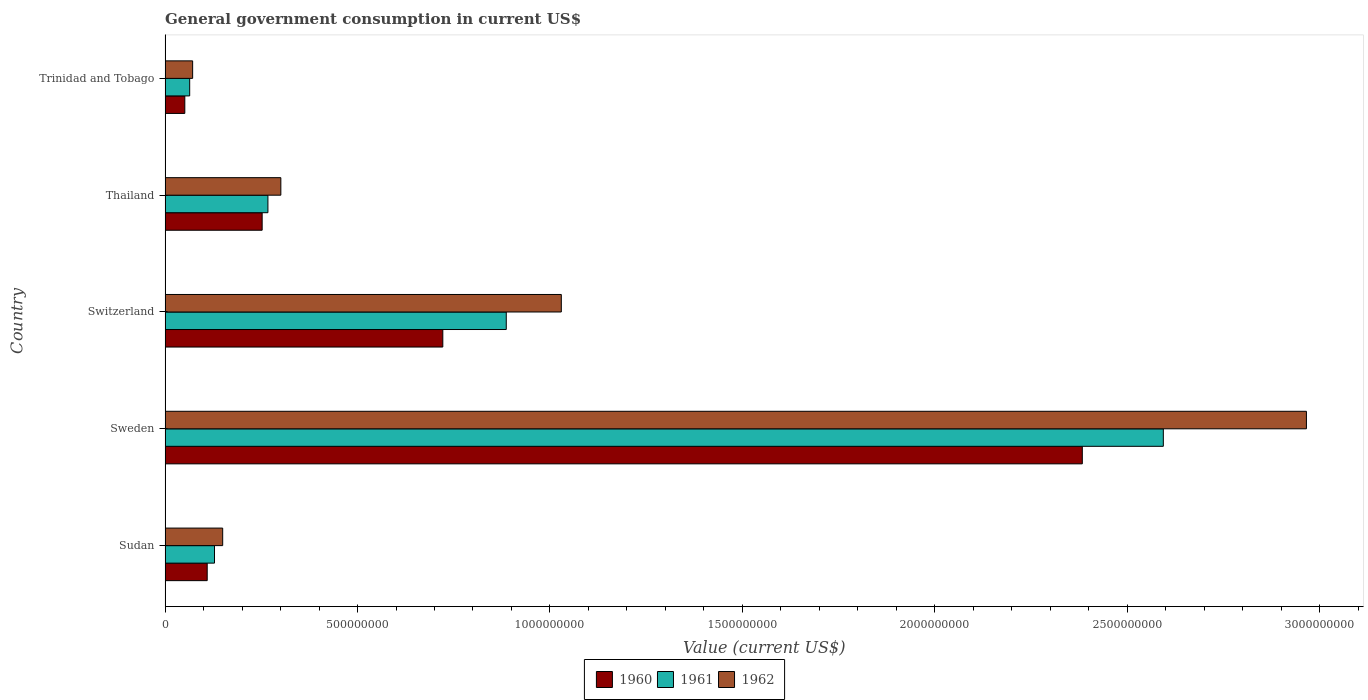How many different coloured bars are there?
Provide a short and direct response. 3. How many groups of bars are there?
Ensure brevity in your answer.  5. Are the number of bars per tick equal to the number of legend labels?
Offer a very short reply. Yes. How many bars are there on the 4th tick from the bottom?
Ensure brevity in your answer.  3. What is the label of the 2nd group of bars from the top?
Give a very brief answer. Thailand. In how many cases, is the number of bars for a given country not equal to the number of legend labels?
Provide a short and direct response. 0. What is the government conusmption in 1960 in Sudan?
Provide a succinct answer. 1.09e+08. Across all countries, what is the maximum government conusmption in 1962?
Provide a short and direct response. 2.97e+09. Across all countries, what is the minimum government conusmption in 1961?
Offer a very short reply. 6.39e+07. In which country was the government conusmption in 1960 maximum?
Give a very brief answer. Sweden. In which country was the government conusmption in 1962 minimum?
Offer a very short reply. Trinidad and Tobago. What is the total government conusmption in 1960 in the graph?
Your answer should be very brief. 3.52e+09. What is the difference between the government conusmption in 1960 in Thailand and that in Trinidad and Tobago?
Keep it short and to the point. 2.01e+08. What is the difference between the government conusmption in 1961 in Thailand and the government conusmption in 1962 in Sweden?
Give a very brief answer. -2.70e+09. What is the average government conusmption in 1961 per country?
Offer a very short reply. 7.88e+08. What is the difference between the government conusmption in 1962 and government conusmption in 1960 in Trinidad and Tobago?
Your answer should be very brief. 2.04e+07. What is the ratio of the government conusmption in 1960 in Sudan to that in Thailand?
Your response must be concise. 0.43. Is the government conusmption in 1960 in Thailand less than that in Trinidad and Tobago?
Your response must be concise. No. What is the difference between the highest and the second highest government conusmption in 1960?
Provide a succinct answer. 1.66e+09. What is the difference between the highest and the lowest government conusmption in 1962?
Your response must be concise. 2.89e+09. In how many countries, is the government conusmption in 1962 greater than the average government conusmption in 1962 taken over all countries?
Your answer should be compact. 2. Is the sum of the government conusmption in 1960 in Sudan and Switzerland greater than the maximum government conusmption in 1961 across all countries?
Your answer should be very brief. No. What does the 1st bar from the bottom in Sweden represents?
Ensure brevity in your answer.  1960. Is it the case that in every country, the sum of the government conusmption in 1961 and government conusmption in 1962 is greater than the government conusmption in 1960?
Your answer should be very brief. Yes. Are the values on the major ticks of X-axis written in scientific E-notation?
Keep it short and to the point. No. Does the graph contain any zero values?
Offer a very short reply. No. How are the legend labels stacked?
Your answer should be very brief. Horizontal. What is the title of the graph?
Provide a short and direct response. General government consumption in current US$. Does "1979" appear as one of the legend labels in the graph?
Provide a short and direct response. No. What is the label or title of the X-axis?
Your response must be concise. Value (current US$). What is the label or title of the Y-axis?
Your response must be concise. Country. What is the Value (current US$) in 1960 in Sudan?
Your answer should be very brief. 1.09e+08. What is the Value (current US$) of 1961 in Sudan?
Provide a short and direct response. 1.28e+08. What is the Value (current US$) in 1962 in Sudan?
Your response must be concise. 1.50e+08. What is the Value (current US$) in 1960 in Sweden?
Keep it short and to the point. 2.38e+09. What is the Value (current US$) of 1961 in Sweden?
Keep it short and to the point. 2.59e+09. What is the Value (current US$) of 1962 in Sweden?
Your answer should be very brief. 2.97e+09. What is the Value (current US$) in 1960 in Switzerland?
Provide a short and direct response. 7.22e+08. What is the Value (current US$) in 1961 in Switzerland?
Your response must be concise. 8.86e+08. What is the Value (current US$) in 1962 in Switzerland?
Ensure brevity in your answer.  1.03e+09. What is the Value (current US$) in 1960 in Thailand?
Your answer should be compact. 2.52e+08. What is the Value (current US$) in 1961 in Thailand?
Provide a short and direct response. 2.67e+08. What is the Value (current US$) in 1962 in Thailand?
Your answer should be compact. 3.01e+08. What is the Value (current US$) in 1960 in Trinidad and Tobago?
Offer a very short reply. 5.12e+07. What is the Value (current US$) of 1961 in Trinidad and Tobago?
Your response must be concise. 6.39e+07. What is the Value (current US$) of 1962 in Trinidad and Tobago?
Your response must be concise. 7.16e+07. Across all countries, what is the maximum Value (current US$) of 1960?
Offer a very short reply. 2.38e+09. Across all countries, what is the maximum Value (current US$) in 1961?
Keep it short and to the point. 2.59e+09. Across all countries, what is the maximum Value (current US$) in 1962?
Provide a short and direct response. 2.97e+09. Across all countries, what is the minimum Value (current US$) of 1960?
Make the answer very short. 5.12e+07. Across all countries, what is the minimum Value (current US$) in 1961?
Give a very brief answer. 6.39e+07. Across all countries, what is the minimum Value (current US$) of 1962?
Provide a succinct answer. 7.16e+07. What is the total Value (current US$) of 1960 in the graph?
Offer a very short reply. 3.52e+09. What is the total Value (current US$) in 1961 in the graph?
Ensure brevity in your answer.  3.94e+09. What is the total Value (current US$) of 1962 in the graph?
Ensure brevity in your answer.  4.52e+09. What is the difference between the Value (current US$) in 1960 in Sudan and that in Sweden?
Your answer should be very brief. -2.27e+09. What is the difference between the Value (current US$) in 1961 in Sudan and that in Sweden?
Your answer should be very brief. -2.47e+09. What is the difference between the Value (current US$) in 1962 in Sudan and that in Sweden?
Make the answer very short. -2.82e+09. What is the difference between the Value (current US$) in 1960 in Sudan and that in Switzerland?
Keep it short and to the point. -6.12e+08. What is the difference between the Value (current US$) of 1961 in Sudan and that in Switzerland?
Your answer should be very brief. -7.58e+08. What is the difference between the Value (current US$) of 1962 in Sudan and that in Switzerland?
Give a very brief answer. -8.80e+08. What is the difference between the Value (current US$) in 1960 in Sudan and that in Thailand?
Your response must be concise. -1.43e+08. What is the difference between the Value (current US$) in 1961 in Sudan and that in Thailand?
Your answer should be very brief. -1.39e+08. What is the difference between the Value (current US$) of 1962 in Sudan and that in Thailand?
Ensure brevity in your answer.  -1.51e+08. What is the difference between the Value (current US$) in 1960 in Sudan and that in Trinidad and Tobago?
Offer a very short reply. 5.82e+07. What is the difference between the Value (current US$) of 1961 in Sudan and that in Trinidad and Tobago?
Ensure brevity in your answer.  6.45e+07. What is the difference between the Value (current US$) of 1962 in Sudan and that in Trinidad and Tobago?
Ensure brevity in your answer.  7.81e+07. What is the difference between the Value (current US$) in 1960 in Sweden and that in Switzerland?
Your answer should be compact. 1.66e+09. What is the difference between the Value (current US$) of 1961 in Sweden and that in Switzerland?
Provide a succinct answer. 1.71e+09. What is the difference between the Value (current US$) in 1962 in Sweden and that in Switzerland?
Give a very brief answer. 1.94e+09. What is the difference between the Value (current US$) of 1960 in Sweden and that in Thailand?
Offer a very short reply. 2.13e+09. What is the difference between the Value (current US$) in 1961 in Sweden and that in Thailand?
Your response must be concise. 2.33e+09. What is the difference between the Value (current US$) in 1962 in Sweden and that in Thailand?
Keep it short and to the point. 2.66e+09. What is the difference between the Value (current US$) in 1960 in Sweden and that in Trinidad and Tobago?
Your answer should be very brief. 2.33e+09. What is the difference between the Value (current US$) in 1961 in Sweden and that in Trinidad and Tobago?
Your response must be concise. 2.53e+09. What is the difference between the Value (current US$) in 1962 in Sweden and that in Trinidad and Tobago?
Your answer should be compact. 2.89e+09. What is the difference between the Value (current US$) in 1960 in Switzerland and that in Thailand?
Provide a succinct answer. 4.69e+08. What is the difference between the Value (current US$) in 1961 in Switzerland and that in Thailand?
Ensure brevity in your answer.  6.19e+08. What is the difference between the Value (current US$) of 1962 in Switzerland and that in Thailand?
Offer a terse response. 7.29e+08. What is the difference between the Value (current US$) in 1960 in Switzerland and that in Trinidad and Tobago?
Provide a short and direct response. 6.70e+08. What is the difference between the Value (current US$) in 1961 in Switzerland and that in Trinidad and Tobago?
Keep it short and to the point. 8.23e+08. What is the difference between the Value (current US$) of 1962 in Switzerland and that in Trinidad and Tobago?
Your response must be concise. 9.58e+08. What is the difference between the Value (current US$) of 1960 in Thailand and that in Trinidad and Tobago?
Provide a short and direct response. 2.01e+08. What is the difference between the Value (current US$) in 1961 in Thailand and that in Trinidad and Tobago?
Offer a very short reply. 2.03e+08. What is the difference between the Value (current US$) in 1962 in Thailand and that in Trinidad and Tobago?
Your answer should be compact. 2.29e+08. What is the difference between the Value (current US$) in 1960 in Sudan and the Value (current US$) in 1961 in Sweden?
Make the answer very short. -2.48e+09. What is the difference between the Value (current US$) of 1960 in Sudan and the Value (current US$) of 1962 in Sweden?
Make the answer very short. -2.86e+09. What is the difference between the Value (current US$) of 1961 in Sudan and the Value (current US$) of 1962 in Sweden?
Keep it short and to the point. -2.84e+09. What is the difference between the Value (current US$) in 1960 in Sudan and the Value (current US$) in 1961 in Switzerland?
Keep it short and to the point. -7.77e+08. What is the difference between the Value (current US$) of 1960 in Sudan and the Value (current US$) of 1962 in Switzerland?
Your answer should be compact. -9.20e+08. What is the difference between the Value (current US$) in 1961 in Sudan and the Value (current US$) in 1962 in Switzerland?
Your response must be concise. -9.01e+08. What is the difference between the Value (current US$) in 1960 in Sudan and the Value (current US$) in 1961 in Thailand?
Make the answer very short. -1.58e+08. What is the difference between the Value (current US$) of 1960 in Sudan and the Value (current US$) of 1962 in Thailand?
Ensure brevity in your answer.  -1.91e+08. What is the difference between the Value (current US$) of 1961 in Sudan and the Value (current US$) of 1962 in Thailand?
Your response must be concise. -1.72e+08. What is the difference between the Value (current US$) of 1960 in Sudan and the Value (current US$) of 1961 in Trinidad and Tobago?
Give a very brief answer. 4.55e+07. What is the difference between the Value (current US$) in 1960 in Sudan and the Value (current US$) in 1962 in Trinidad and Tobago?
Make the answer very short. 3.78e+07. What is the difference between the Value (current US$) in 1961 in Sudan and the Value (current US$) in 1962 in Trinidad and Tobago?
Ensure brevity in your answer.  5.68e+07. What is the difference between the Value (current US$) in 1960 in Sweden and the Value (current US$) in 1961 in Switzerland?
Your answer should be compact. 1.50e+09. What is the difference between the Value (current US$) in 1960 in Sweden and the Value (current US$) in 1962 in Switzerland?
Your answer should be compact. 1.35e+09. What is the difference between the Value (current US$) of 1961 in Sweden and the Value (current US$) of 1962 in Switzerland?
Your answer should be compact. 1.56e+09. What is the difference between the Value (current US$) of 1960 in Sweden and the Value (current US$) of 1961 in Thailand?
Your response must be concise. 2.12e+09. What is the difference between the Value (current US$) of 1960 in Sweden and the Value (current US$) of 1962 in Thailand?
Provide a succinct answer. 2.08e+09. What is the difference between the Value (current US$) in 1961 in Sweden and the Value (current US$) in 1962 in Thailand?
Offer a very short reply. 2.29e+09. What is the difference between the Value (current US$) in 1960 in Sweden and the Value (current US$) in 1961 in Trinidad and Tobago?
Offer a very short reply. 2.32e+09. What is the difference between the Value (current US$) in 1960 in Sweden and the Value (current US$) in 1962 in Trinidad and Tobago?
Provide a succinct answer. 2.31e+09. What is the difference between the Value (current US$) of 1961 in Sweden and the Value (current US$) of 1962 in Trinidad and Tobago?
Your answer should be compact. 2.52e+09. What is the difference between the Value (current US$) in 1960 in Switzerland and the Value (current US$) in 1961 in Thailand?
Your answer should be compact. 4.54e+08. What is the difference between the Value (current US$) of 1960 in Switzerland and the Value (current US$) of 1962 in Thailand?
Keep it short and to the point. 4.21e+08. What is the difference between the Value (current US$) in 1961 in Switzerland and the Value (current US$) in 1962 in Thailand?
Your answer should be compact. 5.86e+08. What is the difference between the Value (current US$) of 1960 in Switzerland and the Value (current US$) of 1961 in Trinidad and Tobago?
Your response must be concise. 6.58e+08. What is the difference between the Value (current US$) in 1960 in Switzerland and the Value (current US$) in 1962 in Trinidad and Tobago?
Provide a succinct answer. 6.50e+08. What is the difference between the Value (current US$) of 1961 in Switzerland and the Value (current US$) of 1962 in Trinidad and Tobago?
Your answer should be very brief. 8.15e+08. What is the difference between the Value (current US$) in 1960 in Thailand and the Value (current US$) in 1961 in Trinidad and Tobago?
Make the answer very short. 1.88e+08. What is the difference between the Value (current US$) in 1960 in Thailand and the Value (current US$) in 1962 in Trinidad and Tobago?
Give a very brief answer. 1.81e+08. What is the difference between the Value (current US$) in 1961 in Thailand and the Value (current US$) in 1962 in Trinidad and Tobago?
Your answer should be compact. 1.96e+08. What is the average Value (current US$) of 1960 per country?
Your answer should be very brief. 7.04e+08. What is the average Value (current US$) of 1961 per country?
Your answer should be very brief. 7.88e+08. What is the average Value (current US$) of 1962 per country?
Your answer should be compact. 9.03e+08. What is the difference between the Value (current US$) in 1960 and Value (current US$) in 1961 in Sudan?
Give a very brief answer. -1.90e+07. What is the difference between the Value (current US$) of 1960 and Value (current US$) of 1962 in Sudan?
Keep it short and to the point. -4.02e+07. What is the difference between the Value (current US$) in 1961 and Value (current US$) in 1962 in Sudan?
Provide a short and direct response. -2.13e+07. What is the difference between the Value (current US$) in 1960 and Value (current US$) in 1961 in Sweden?
Ensure brevity in your answer.  -2.10e+08. What is the difference between the Value (current US$) in 1960 and Value (current US$) in 1962 in Sweden?
Offer a very short reply. -5.82e+08. What is the difference between the Value (current US$) in 1961 and Value (current US$) in 1962 in Sweden?
Offer a terse response. -3.72e+08. What is the difference between the Value (current US$) in 1960 and Value (current US$) in 1961 in Switzerland?
Your response must be concise. -1.65e+08. What is the difference between the Value (current US$) of 1960 and Value (current US$) of 1962 in Switzerland?
Your answer should be very brief. -3.08e+08. What is the difference between the Value (current US$) of 1961 and Value (current US$) of 1962 in Switzerland?
Keep it short and to the point. -1.43e+08. What is the difference between the Value (current US$) of 1960 and Value (current US$) of 1961 in Thailand?
Your answer should be compact. -1.50e+07. What is the difference between the Value (current US$) of 1960 and Value (current US$) of 1962 in Thailand?
Ensure brevity in your answer.  -4.86e+07. What is the difference between the Value (current US$) in 1961 and Value (current US$) in 1962 in Thailand?
Provide a succinct answer. -3.36e+07. What is the difference between the Value (current US$) of 1960 and Value (current US$) of 1961 in Trinidad and Tobago?
Make the answer very short. -1.27e+07. What is the difference between the Value (current US$) in 1960 and Value (current US$) in 1962 in Trinidad and Tobago?
Your answer should be very brief. -2.04e+07. What is the difference between the Value (current US$) in 1961 and Value (current US$) in 1962 in Trinidad and Tobago?
Offer a terse response. -7.70e+06. What is the ratio of the Value (current US$) of 1960 in Sudan to that in Sweden?
Offer a terse response. 0.05. What is the ratio of the Value (current US$) of 1961 in Sudan to that in Sweden?
Your answer should be compact. 0.05. What is the ratio of the Value (current US$) in 1962 in Sudan to that in Sweden?
Provide a short and direct response. 0.05. What is the ratio of the Value (current US$) of 1960 in Sudan to that in Switzerland?
Ensure brevity in your answer.  0.15. What is the ratio of the Value (current US$) in 1961 in Sudan to that in Switzerland?
Make the answer very short. 0.14. What is the ratio of the Value (current US$) of 1962 in Sudan to that in Switzerland?
Give a very brief answer. 0.15. What is the ratio of the Value (current US$) of 1960 in Sudan to that in Thailand?
Offer a very short reply. 0.43. What is the ratio of the Value (current US$) of 1961 in Sudan to that in Thailand?
Give a very brief answer. 0.48. What is the ratio of the Value (current US$) in 1962 in Sudan to that in Thailand?
Offer a very short reply. 0.5. What is the ratio of the Value (current US$) of 1960 in Sudan to that in Trinidad and Tobago?
Offer a terse response. 2.14. What is the ratio of the Value (current US$) in 1961 in Sudan to that in Trinidad and Tobago?
Give a very brief answer. 2.01. What is the ratio of the Value (current US$) in 1962 in Sudan to that in Trinidad and Tobago?
Ensure brevity in your answer.  2.09. What is the ratio of the Value (current US$) of 1960 in Sweden to that in Switzerland?
Offer a terse response. 3.3. What is the ratio of the Value (current US$) in 1961 in Sweden to that in Switzerland?
Provide a succinct answer. 2.93. What is the ratio of the Value (current US$) of 1962 in Sweden to that in Switzerland?
Keep it short and to the point. 2.88. What is the ratio of the Value (current US$) of 1960 in Sweden to that in Thailand?
Give a very brief answer. 9.45. What is the ratio of the Value (current US$) of 1961 in Sweden to that in Thailand?
Your response must be concise. 9.71. What is the ratio of the Value (current US$) in 1962 in Sweden to that in Thailand?
Provide a short and direct response. 9.86. What is the ratio of the Value (current US$) in 1960 in Sweden to that in Trinidad and Tobago?
Your answer should be compact. 46.53. What is the ratio of the Value (current US$) of 1961 in Sweden to that in Trinidad and Tobago?
Give a very brief answer. 40.61. What is the ratio of the Value (current US$) of 1962 in Sweden to that in Trinidad and Tobago?
Your response must be concise. 41.43. What is the ratio of the Value (current US$) in 1960 in Switzerland to that in Thailand?
Your answer should be very brief. 2.86. What is the ratio of the Value (current US$) in 1961 in Switzerland to that in Thailand?
Provide a succinct answer. 3.32. What is the ratio of the Value (current US$) in 1962 in Switzerland to that in Thailand?
Give a very brief answer. 3.42. What is the ratio of the Value (current US$) of 1960 in Switzerland to that in Trinidad and Tobago?
Offer a very short reply. 14.09. What is the ratio of the Value (current US$) of 1961 in Switzerland to that in Trinidad and Tobago?
Offer a very short reply. 13.88. What is the ratio of the Value (current US$) of 1962 in Switzerland to that in Trinidad and Tobago?
Keep it short and to the point. 14.38. What is the ratio of the Value (current US$) of 1960 in Thailand to that in Trinidad and Tobago?
Ensure brevity in your answer.  4.92. What is the ratio of the Value (current US$) in 1961 in Thailand to that in Trinidad and Tobago?
Your answer should be very brief. 4.18. What is the ratio of the Value (current US$) in 1962 in Thailand to that in Trinidad and Tobago?
Your answer should be very brief. 4.2. What is the difference between the highest and the second highest Value (current US$) of 1960?
Ensure brevity in your answer.  1.66e+09. What is the difference between the highest and the second highest Value (current US$) of 1961?
Offer a terse response. 1.71e+09. What is the difference between the highest and the second highest Value (current US$) in 1962?
Ensure brevity in your answer.  1.94e+09. What is the difference between the highest and the lowest Value (current US$) in 1960?
Provide a succinct answer. 2.33e+09. What is the difference between the highest and the lowest Value (current US$) of 1961?
Provide a short and direct response. 2.53e+09. What is the difference between the highest and the lowest Value (current US$) of 1962?
Your answer should be compact. 2.89e+09. 